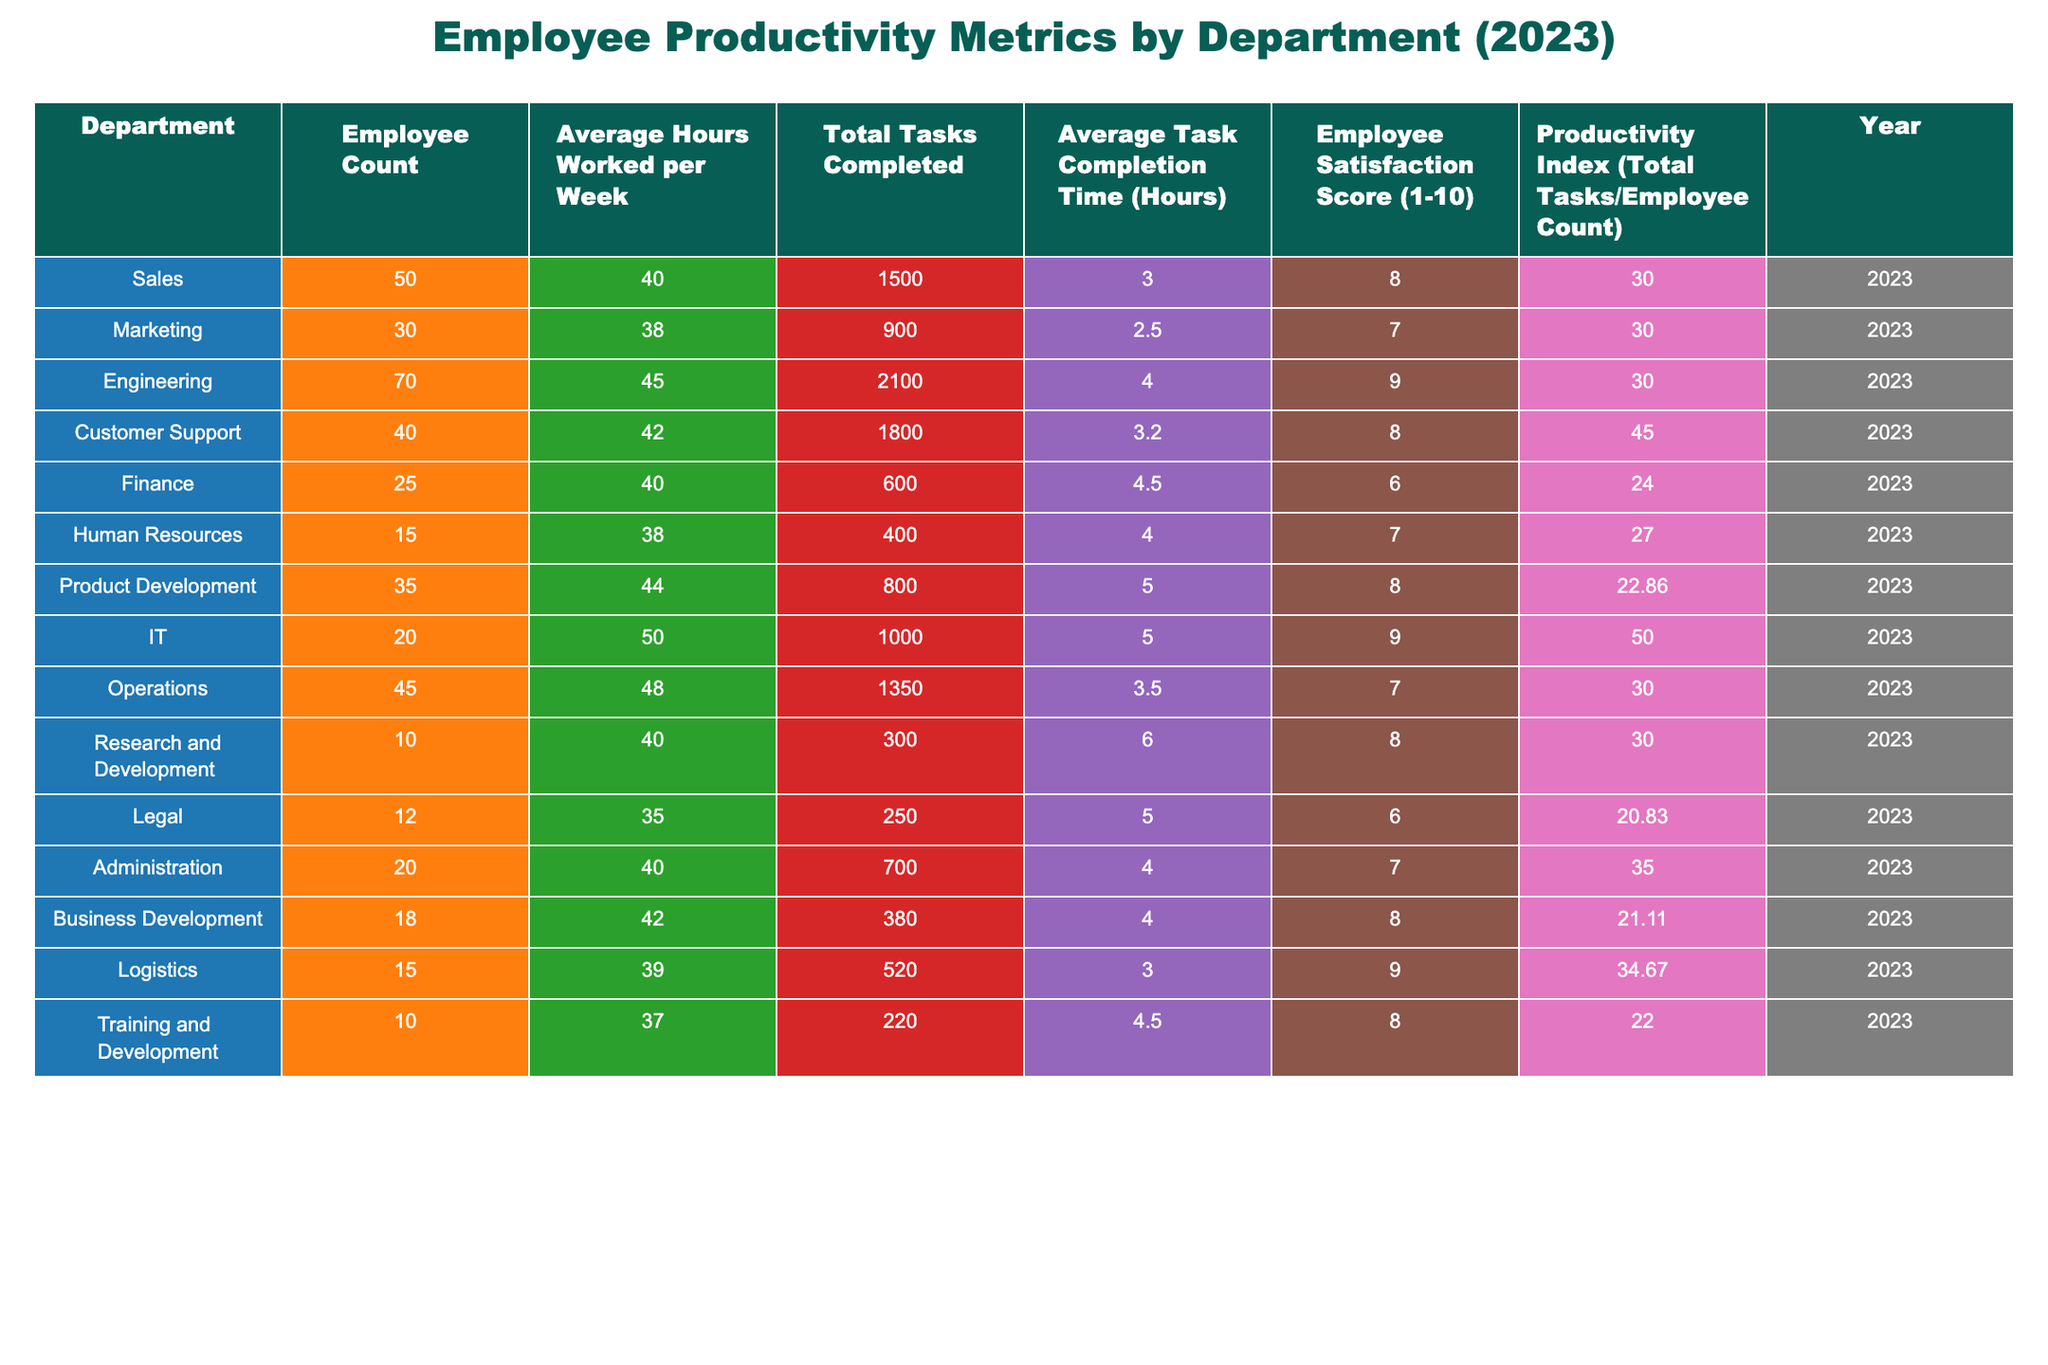What is the average employee satisfaction score across all departments? To find the average employee satisfaction score, sum the scores for all departments (8 + 7 + 9 + 8 + 6 + 7 + 8 + 9 + 7 + 8 + 6 + 7 + 8) which equals 97, then divide by the number of departments (13). Thus, 97 / 13 gives an average of approximately 7.46.
Answer: 7.46 Which department had the highest productivity index? Looking at the productivity index for each department, IT has the highest value of 50 compared to others.
Answer: IT What is the total number of tasks completed by the Customer Support department? The table indicates that the Customer Support department completed a total of 1,800 tasks in 2023.
Answer: 1800 Which department has the lowest average task completion time? By examining the average task completion time for each department, Finance has the lowest completion time of 4.5 hours.
Answer: Finance What is the difference in employee count between the Sales and Marketing departments? The Sales department has 50 employees, while Marketing has 30. The difference is 50 - 30 = 20.
Answer: 20 Is the average hours worked per week by the IT department greater than the overall average for all departments? First, calculate the overall average hours worked: (40 + 38 + 45 + 42 + 40 + 38 + 44 + 50 + 48 + 40 + 35 + 40 + 37) = 41.62. The IT department works 50 hours, which is greater than 41.62.
Answer: Yes What is the combined total of tasks completed by the Finance and Human Resources departments? For Finance, 600 tasks were completed, and for Human Resources, 400 tasks were completed. The total is 600 + 400 = 1000.
Answer: 1000 How does the employee count in the Engineering department compare to the average employee count across all departments? Engineering has 70 employees. First, calculate the average employee count across all departments: (50 + 30 + 70 + 40 + 25 + 15 + 35 + 20 + 45 + 10 + 12 + 20 + 18 + 15 + 10) / 15 = 31. The Engineering department has more employees than this average.
Answer: More If we compare the employee satisfaction score of Logistics and Operations, which department has a higher score? Logistics has a score of 9, whereas Operations has a score of 7. Hence, Logistics has the higher score.
Answer: Logistics Which department's productivity index is closest to the average productivity index across all departments? First, calculate the average productivity index: (30 + 30 + 30 + 45 + 24 + 27 + 22.86 + 50 + 30 + 30 + 20.83 + 35 + 21.11 + 34.67 + 22) / 15 = 29.69. The closest index to this average is from the Sales, Marketing, Engineering, and Operations departments, all at 30.
Answer: Sales, Marketing, Engineering, Operations What is the total average hours worked by all departments combined? To find the total average hours, sum the average hours per department (40 + 38 + 45 + 42 + 40 + 38 + 44 + 50 + 48 + 40 + 35 + 40 + 37) = 41.62 hours.
Answer: 41.62 